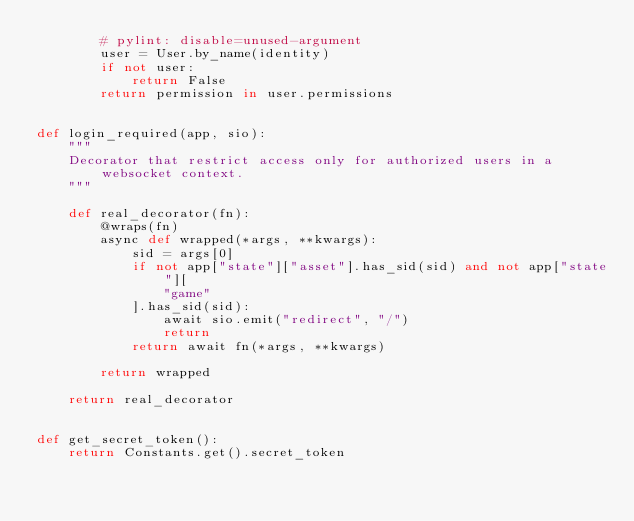<code> <loc_0><loc_0><loc_500><loc_500><_Python_>        # pylint: disable=unused-argument
        user = User.by_name(identity)
        if not user:
            return False
        return permission in user.permissions


def login_required(app, sio):
    """
    Decorator that restrict access only for authorized users in a websocket context.
    """

    def real_decorator(fn):
        @wraps(fn)
        async def wrapped(*args, **kwargs):
            sid = args[0]
            if not app["state"]["asset"].has_sid(sid) and not app["state"][
                "game"
            ].has_sid(sid):
                await sio.emit("redirect", "/")
                return
            return await fn(*args, **kwargs)

        return wrapped

    return real_decorator


def get_secret_token():
    return Constants.get().secret_token
</code> 